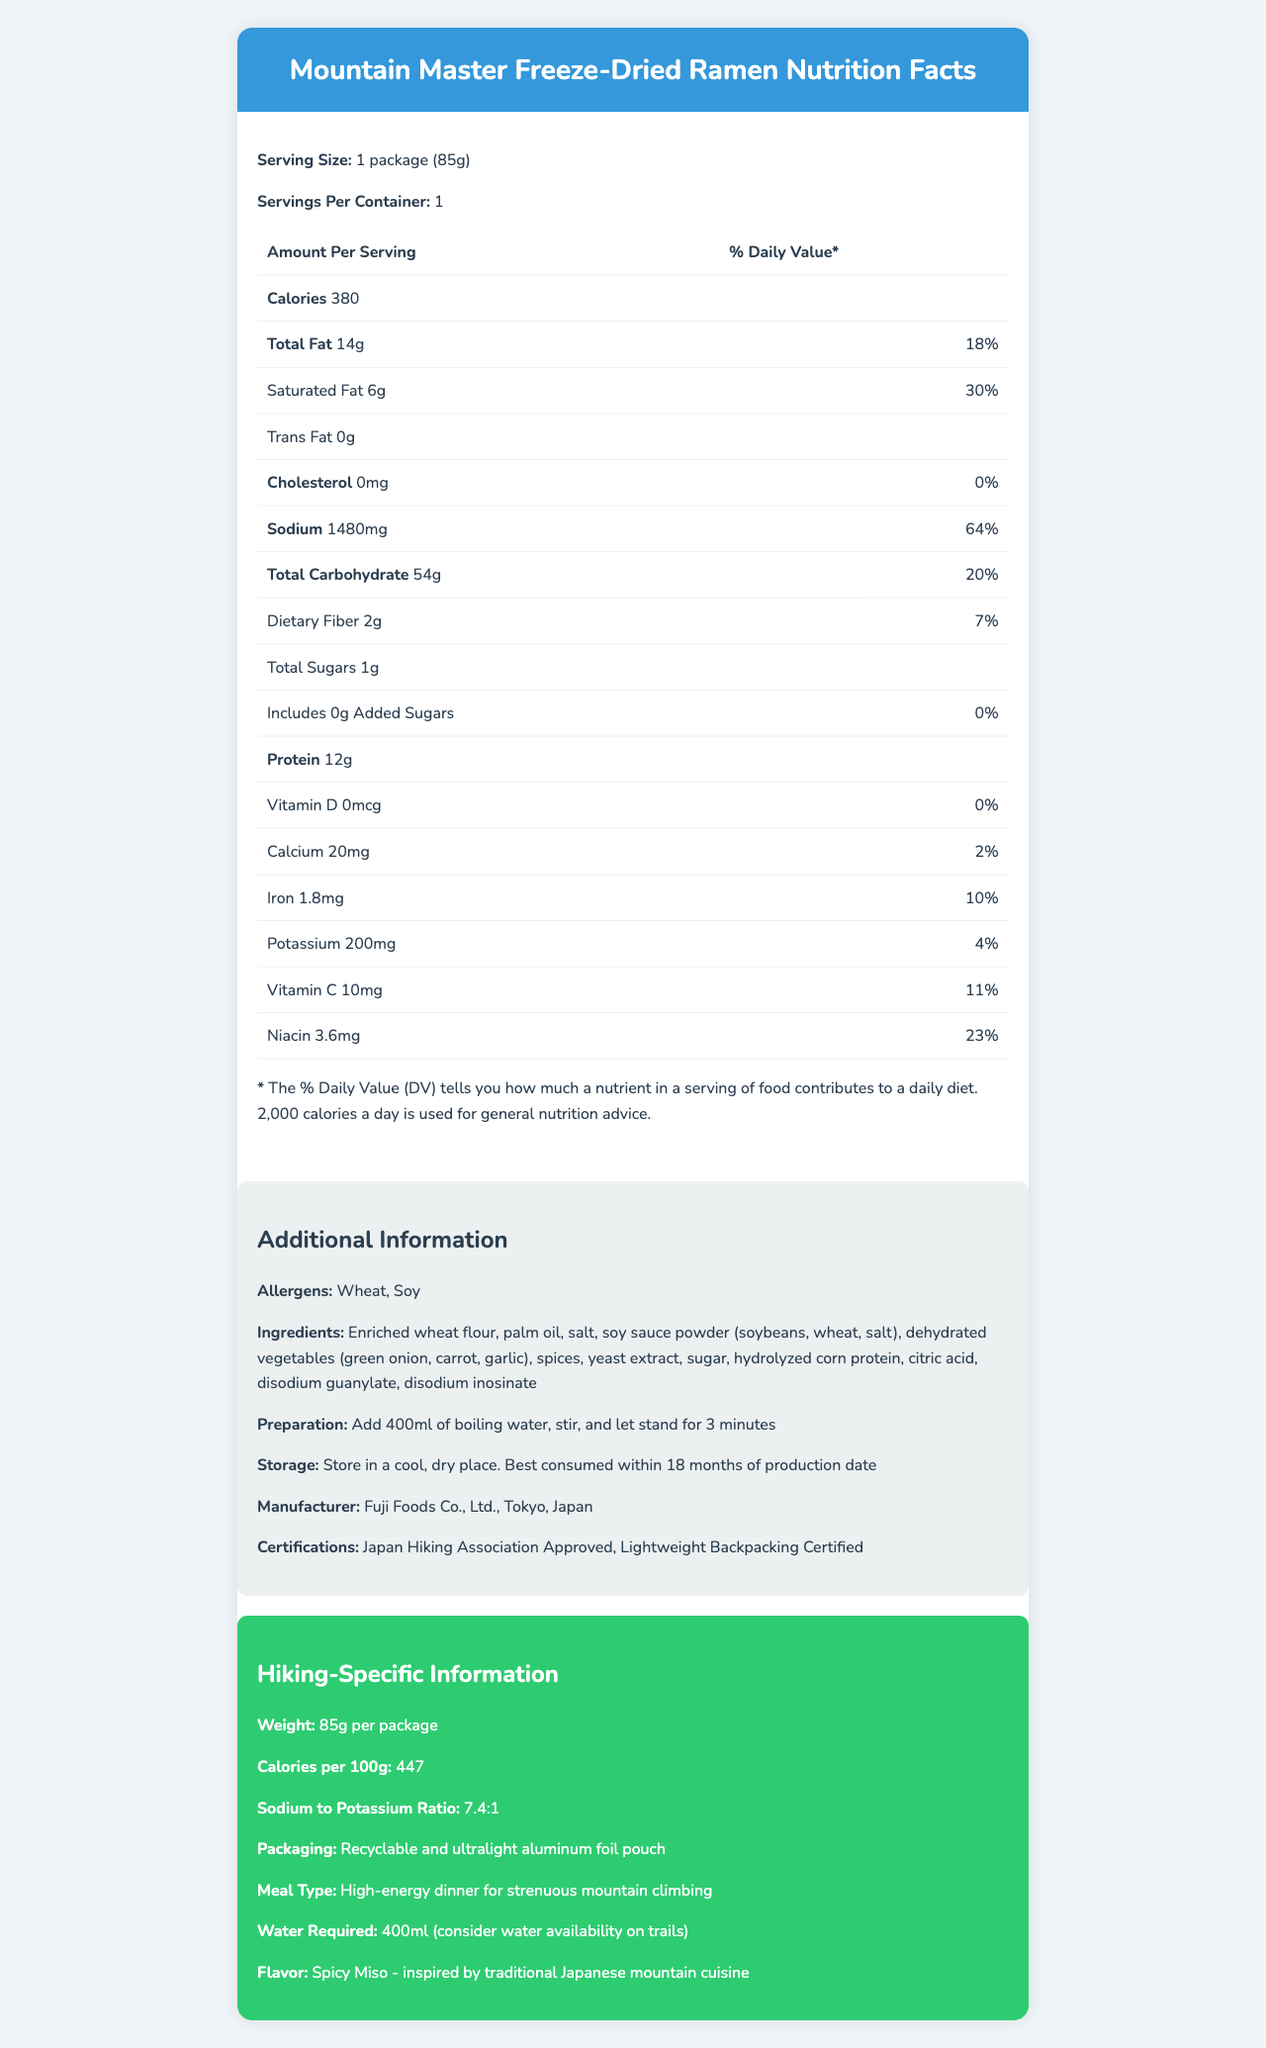what is the serving size for Mountain Master Freeze-Dried Ramen? The document states that the serving size is 1 package (85g).
Answer: 1 package (85g) how many calories are there per serving? The nutrition table shows that there are 380 calories per serving.
Answer: 380 what is the total fat content per serving? According to the document, the total fat content per serving is 14g.
Answer: 14g what is the serving's daily value percentage of sodium? The nutrition table indicates that the daily value percentage of sodium per serving is 64%.
Answer: 64% how many grams of protein are in one serving? The document lists that there are 12g of protein in one serving.
Answer: 12g how much water is required to prepare the ramen? A. 200ml B. 300ml C. 400ml D. 500ml The preparation section states that 400ml of boiling water is required.
Answer: C. 400ml which vitamin has the highest daily value percentage per serving? I. Vitamin D II. Calcium III. Iron IV. Vitamin C Vitamin C has a daily value percentage of 11%, which is the highest among the listed vitamins and minerals.
Answer: IV. Vitamin C are there any allergens listed in the ramen? The additional information section lists Wheat and Soy as allergens.
Answer: Yes what is the recommended storage condition for this product? The additional information section provides these storage instructions.
Answer: Store in a cool, dry place. Best consumed within 18 months of production date describe the flavor of this ramen. The hiking-specific information section describes the flavor as Spicy Miso inspired by traditional Japanese mountain cuisine.
Answer: Spicy Miso - inspired by traditional Japanese mountain cuisine which company manufactures the Mountain Master Freeze-Dried Ramen? The additional information section states that the manufacturer is Fuji Foods Co., Ltd., located in Tokyo, Japan.
Answer: Fuji Foods Co., Ltd., Tokyo, Japan what are the main ideas presented in the document? The document covers all essential aspects of the nutrition, usability, and hiking-specific features of the product, making it suitable for backpackers in Japan's mountains.
Answer: The document provides detailed nutrition facts, preparation instructions, storage guidelines, ingredient list, manufacturer information, and specific details designed for hikers for the freeze-dried ramen product called Mountain Master Freeze-Dried Ramen. what is the ratio of sodium to potassium in the ramen? The hiking-specific information section states that the sodium to potassium ratio is 7.4:1.
Answer: 7.4:1 how is the package of the ramen designed for the environment? The hiking-specific information section states that the packaging is recyclable and made from ultralight aluminum foil.
Answer: Recyclable and ultralight aluminum foil pouch which certifications does this product have? The document mentions these certifications in the additional information section.
Answer: Japan Hiking Association Approved, Lightweight Backpacking Certified how is the freeze-dried ramen prepared? The preparation section provides these instructions.
Answer: Add 400ml of boiling water, stir, and let stand for 3 minutes how many total carbohydrates are there per serving? The nutrition table states that there are 54g of total carbohydrates per serving.
Answer: 54g is there any added sugar in this ramen? The nutrition table indicates that there is 0g of added sugars.
Answer: No how much fiber is in one serving? The document lists the dietary fiber content as 2g per serving.
Answer: 2g what is the best before date for this product? The document mentions it is best consumed within 18 months of production date but does not provide an exact date.
Answer: Not enough information 